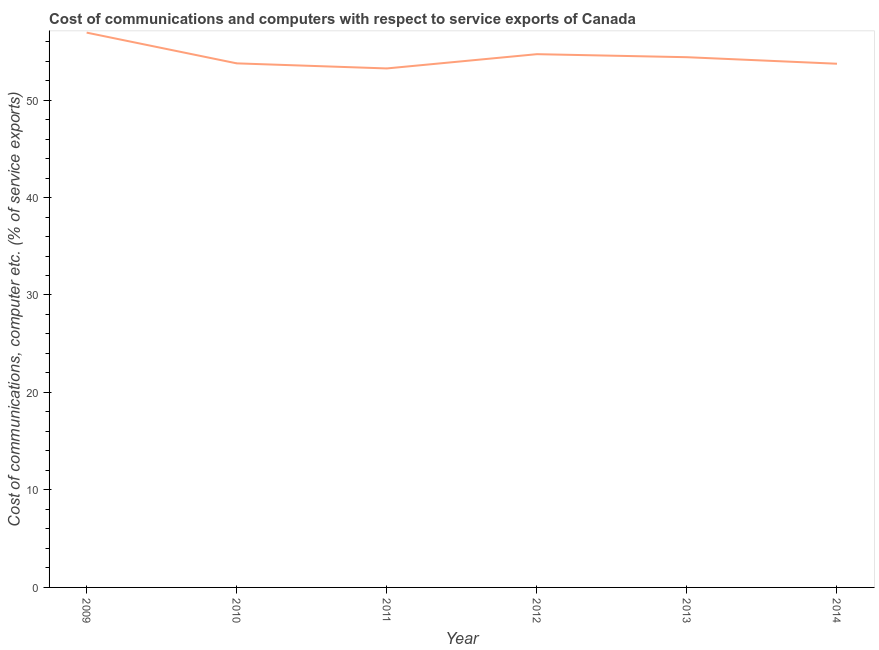What is the cost of communications and computer in 2010?
Ensure brevity in your answer.  53.76. Across all years, what is the maximum cost of communications and computer?
Your response must be concise. 56.92. Across all years, what is the minimum cost of communications and computer?
Give a very brief answer. 53.24. In which year was the cost of communications and computer maximum?
Offer a terse response. 2009. In which year was the cost of communications and computer minimum?
Your answer should be compact. 2011. What is the sum of the cost of communications and computer?
Your answer should be compact. 326.75. What is the difference between the cost of communications and computer in 2011 and 2012?
Your answer should be very brief. -1.46. What is the average cost of communications and computer per year?
Your answer should be very brief. 54.46. What is the median cost of communications and computer?
Offer a terse response. 54.08. In how many years, is the cost of communications and computer greater than 14 %?
Offer a terse response. 6. What is the ratio of the cost of communications and computer in 2012 to that in 2013?
Offer a very short reply. 1.01. Is the cost of communications and computer in 2010 less than that in 2014?
Offer a terse response. No. Is the difference between the cost of communications and computer in 2012 and 2013 greater than the difference between any two years?
Provide a succinct answer. No. What is the difference between the highest and the second highest cost of communications and computer?
Ensure brevity in your answer.  2.21. Is the sum of the cost of communications and computer in 2009 and 2014 greater than the maximum cost of communications and computer across all years?
Your answer should be compact. Yes. What is the difference between the highest and the lowest cost of communications and computer?
Keep it short and to the point. 3.67. In how many years, is the cost of communications and computer greater than the average cost of communications and computer taken over all years?
Give a very brief answer. 2. How many lines are there?
Ensure brevity in your answer.  1. How many years are there in the graph?
Your answer should be compact. 6. What is the difference between two consecutive major ticks on the Y-axis?
Your answer should be very brief. 10. Are the values on the major ticks of Y-axis written in scientific E-notation?
Keep it short and to the point. No. Does the graph contain any zero values?
Your answer should be compact. No. What is the title of the graph?
Keep it short and to the point. Cost of communications and computers with respect to service exports of Canada. What is the label or title of the X-axis?
Ensure brevity in your answer.  Year. What is the label or title of the Y-axis?
Offer a terse response. Cost of communications, computer etc. (% of service exports). What is the Cost of communications, computer etc. (% of service exports) of 2009?
Ensure brevity in your answer.  56.92. What is the Cost of communications, computer etc. (% of service exports) of 2010?
Offer a very short reply. 53.76. What is the Cost of communications, computer etc. (% of service exports) of 2011?
Provide a short and direct response. 53.24. What is the Cost of communications, computer etc. (% of service exports) in 2012?
Provide a short and direct response. 54.71. What is the Cost of communications, computer etc. (% of service exports) in 2013?
Your answer should be compact. 54.39. What is the Cost of communications, computer etc. (% of service exports) in 2014?
Ensure brevity in your answer.  53.73. What is the difference between the Cost of communications, computer etc. (% of service exports) in 2009 and 2010?
Your answer should be very brief. 3.15. What is the difference between the Cost of communications, computer etc. (% of service exports) in 2009 and 2011?
Keep it short and to the point. 3.67. What is the difference between the Cost of communications, computer etc. (% of service exports) in 2009 and 2012?
Offer a very short reply. 2.21. What is the difference between the Cost of communications, computer etc. (% of service exports) in 2009 and 2013?
Your answer should be compact. 2.52. What is the difference between the Cost of communications, computer etc. (% of service exports) in 2009 and 2014?
Offer a terse response. 3.19. What is the difference between the Cost of communications, computer etc. (% of service exports) in 2010 and 2011?
Ensure brevity in your answer.  0.52. What is the difference between the Cost of communications, computer etc. (% of service exports) in 2010 and 2012?
Provide a succinct answer. -0.94. What is the difference between the Cost of communications, computer etc. (% of service exports) in 2010 and 2013?
Provide a short and direct response. -0.63. What is the difference between the Cost of communications, computer etc. (% of service exports) in 2010 and 2014?
Offer a terse response. 0.04. What is the difference between the Cost of communications, computer etc. (% of service exports) in 2011 and 2012?
Keep it short and to the point. -1.46. What is the difference between the Cost of communications, computer etc. (% of service exports) in 2011 and 2013?
Make the answer very short. -1.15. What is the difference between the Cost of communications, computer etc. (% of service exports) in 2011 and 2014?
Ensure brevity in your answer.  -0.48. What is the difference between the Cost of communications, computer etc. (% of service exports) in 2012 and 2013?
Your answer should be compact. 0.31. What is the difference between the Cost of communications, computer etc. (% of service exports) in 2012 and 2014?
Ensure brevity in your answer.  0.98. What is the difference between the Cost of communications, computer etc. (% of service exports) in 2013 and 2014?
Your answer should be compact. 0.67. What is the ratio of the Cost of communications, computer etc. (% of service exports) in 2009 to that in 2010?
Provide a succinct answer. 1.06. What is the ratio of the Cost of communications, computer etc. (% of service exports) in 2009 to that in 2011?
Ensure brevity in your answer.  1.07. What is the ratio of the Cost of communications, computer etc. (% of service exports) in 2009 to that in 2012?
Ensure brevity in your answer.  1.04. What is the ratio of the Cost of communications, computer etc. (% of service exports) in 2009 to that in 2013?
Keep it short and to the point. 1.05. What is the ratio of the Cost of communications, computer etc. (% of service exports) in 2009 to that in 2014?
Keep it short and to the point. 1.06. What is the ratio of the Cost of communications, computer etc. (% of service exports) in 2010 to that in 2012?
Offer a very short reply. 0.98. What is the ratio of the Cost of communications, computer etc. (% of service exports) in 2010 to that in 2014?
Your answer should be very brief. 1. What is the ratio of the Cost of communications, computer etc. (% of service exports) in 2011 to that in 2012?
Your response must be concise. 0.97. What is the ratio of the Cost of communications, computer etc. (% of service exports) in 2011 to that in 2013?
Your answer should be compact. 0.98. What is the ratio of the Cost of communications, computer etc. (% of service exports) in 2012 to that in 2013?
Give a very brief answer. 1.01. 